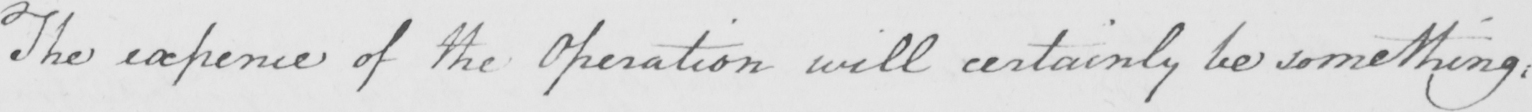What does this handwritten line say? The expence of the Operation will certainly be something , 